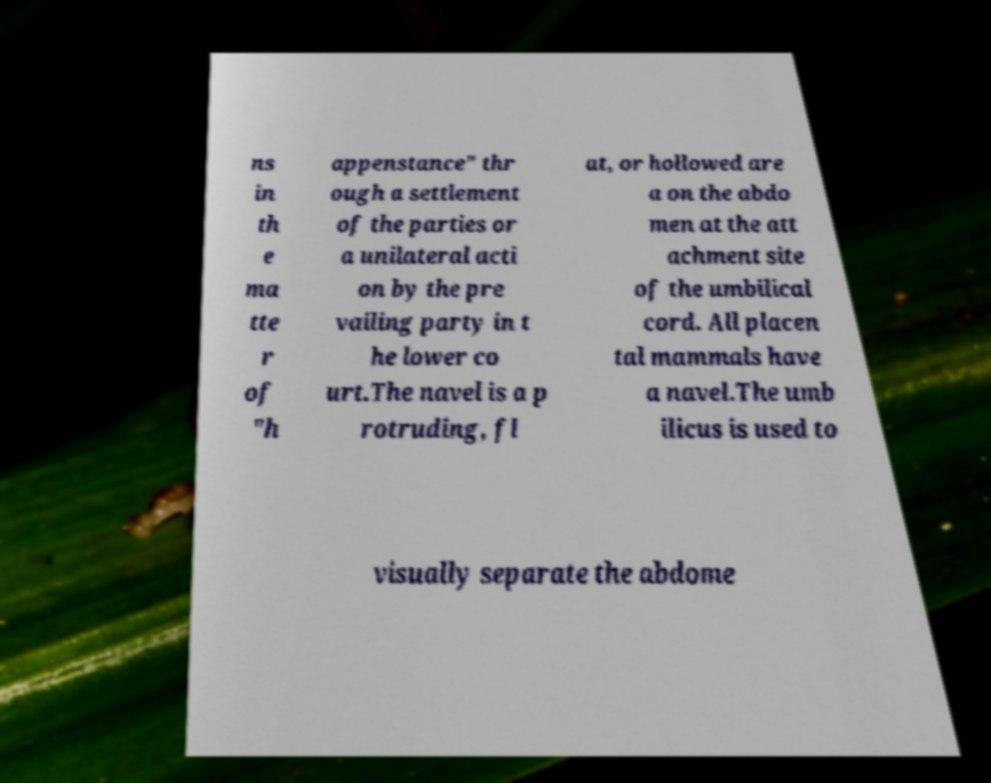Could you extract and type out the text from this image? ns in th e ma tte r of "h appenstance" thr ough a settlement of the parties or a unilateral acti on by the pre vailing party in t he lower co urt.The navel is a p rotruding, fl at, or hollowed are a on the abdo men at the att achment site of the umbilical cord. All placen tal mammals have a navel.The umb ilicus is used to visually separate the abdome 